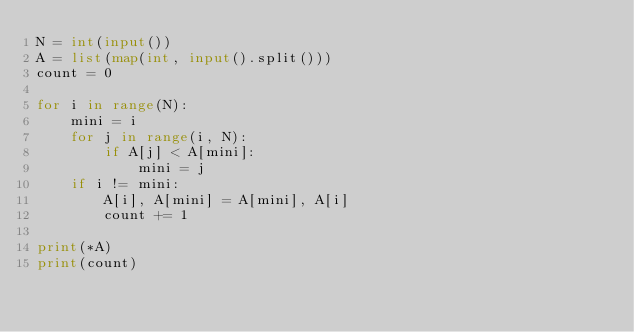<code> <loc_0><loc_0><loc_500><loc_500><_Python_>N = int(input())
A = list(map(int, input().split()))
count = 0

for i in range(N):
    mini = i
    for j in range(i, N):
        if A[j] < A[mini]:
            mini = j
    if i != mini:
        A[i], A[mini] = A[mini], A[i]
        count += 1

print(*A)
print(count)</code> 